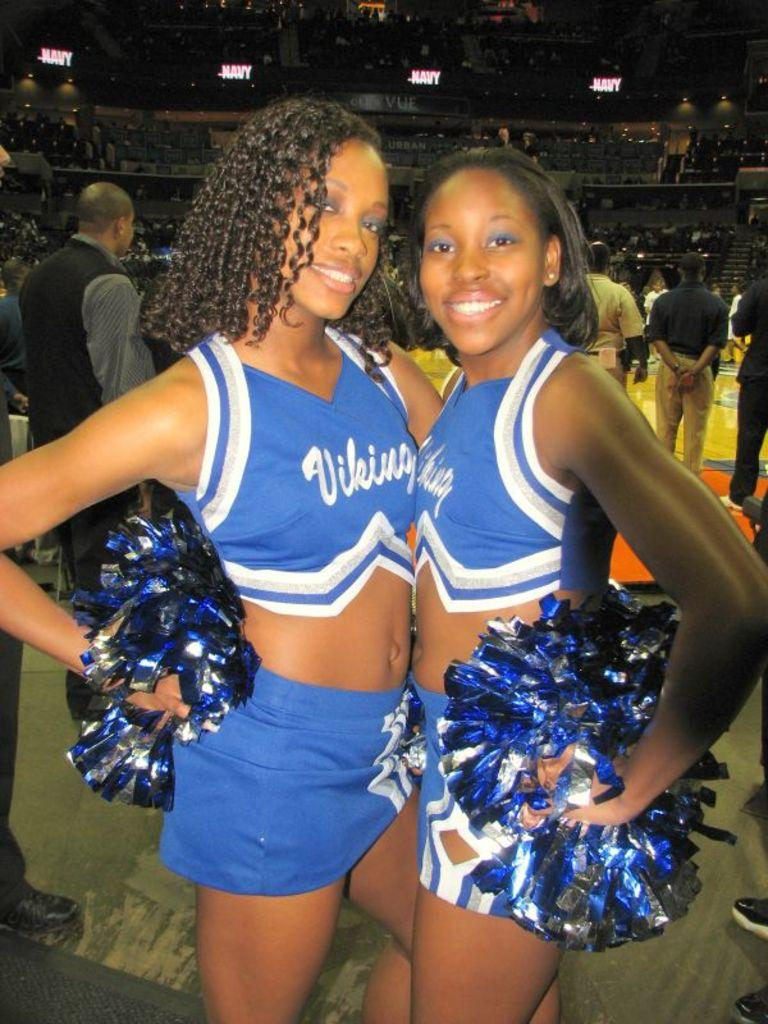<image>
Describe the image concisely. Two cheerleaders in blue Viking shirts smiling next to each other. 